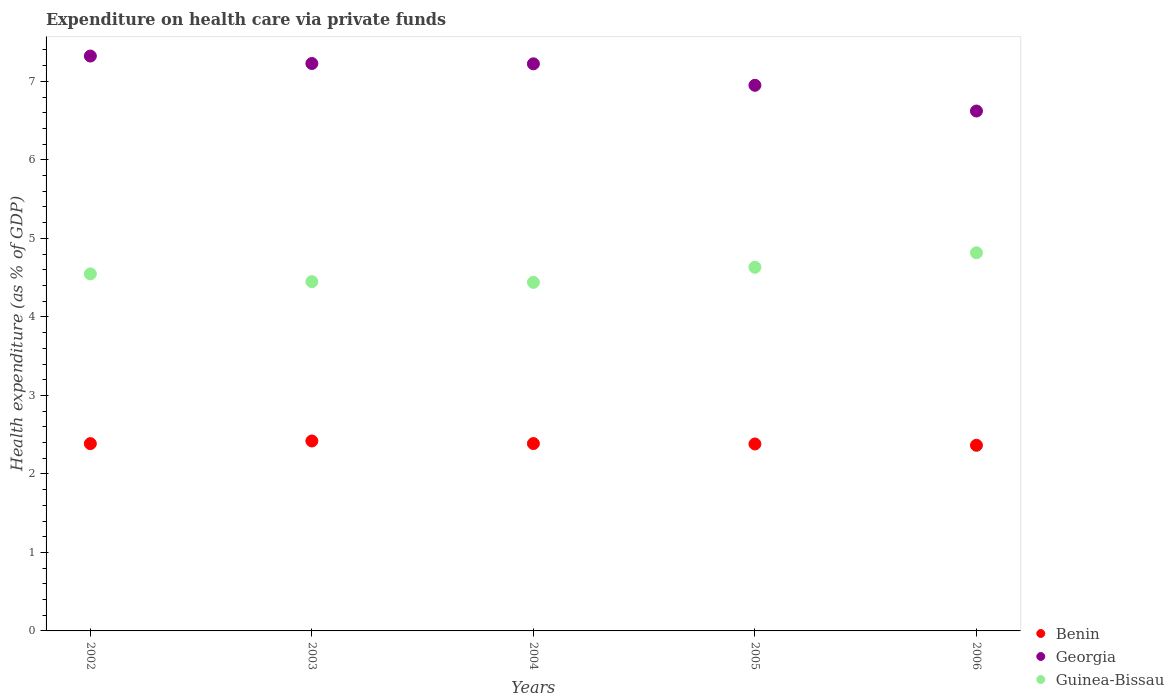How many different coloured dotlines are there?
Provide a succinct answer. 3. What is the expenditure made on health care in Guinea-Bissau in 2003?
Make the answer very short. 4.45. Across all years, what is the maximum expenditure made on health care in Georgia?
Your response must be concise. 7.32. Across all years, what is the minimum expenditure made on health care in Benin?
Your answer should be compact. 2.36. In which year was the expenditure made on health care in Guinea-Bissau minimum?
Keep it short and to the point. 2004. What is the total expenditure made on health care in Benin in the graph?
Your response must be concise. 11.94. What is the difference between the expenditure made on health care in Georgia in 2002 and that in 2003?
Ensure brevity in your answer.  0.1. What is the difference between the expenditure made on health care in Guinea-Bissau in 2004 and the expenditure made on health care in Georgia in 2002?
Make the answer very short. -2.88. What is the average expenditure made on health care in Guinea-Bissau per year?
Your answer should be very brief. 4.58. In the year 2005, what is the difference between the expenditure made on health care in Benin and expenditure made on health care in Guinea-Bissau?
Keep it short and to the point. -2.25. In how many years, is the expenditure made on health care in Benin greater than 6.8 %?
Offer a terse response. 0. What is the ratio of the expenditure made on health care in Benin in 2003 to that in 2005?
Keep it short and to the point. 1.02. Is the difference between the expenditure made on health care in Benin in 2005 and 2006 greater than the difference between the expenditure made on health care in Guinea-Bissau in 2005 and 2006?
Offer a terse response. Yes. What is the difference between the highest and the second highest expenditure made on health care in Georgia?
Your answer should be compact. 0.1. What is the difference between the highest and the lowest expenditure made on health care in Guinea-Bissau?
Offer a very short reply. 0.38. Is the sum of the expenditure made on health care in Guinea-Bissau in 2002 and 2004 greater than the maximum expenditure made on health care in Georgia across all years?
Ensure brevity in your answer.  Yes. Is it the case that in every year, the sum of the expenditure made on health care in Benin and expenditure made on health care in Georgia  is greater than the expenditure made on health care in Guinea-Bissau?
Give a very brief answer. Yes. Does the expenditure made on health care in Guinea-Bissau monotonically increase over the years?
Your response must be concise. No. Is the expenditure made on health care in Georgia strictly greater than the expenditure made on health care in Benin over the years?
Offer a very short reply. Yes. Is the expenditure made on health care in Benin strictly less than the expenditure made on health care in Guinea-Bissau over the years?
Make the answer very short. Yes. How many dotlines are there?
Give a very brief answer. 3. What is the difference between two consecutive major ticks on the Y-axis?
Your answer should be compact. 1. Are the values on the major ticks of Y-axis written in scientific E-notation?
Provide a succinct answer. No. Does the graph contain any zero values?
Offer a terse response. No. Does the graph contain grids?
Give a very brief answer. No. Where does the legend appear in the graph?
Provide a short and direct response. Bottom right. How many legend labels are there?
Your answer should be very brief. 3. What is the title of the graph?
Your response must be concise. Expenditure on health care via private funds. What is the label or title of the X-axis?
Offer a terse response. Years. What is the label or title of the Y-axis?
Provide a short and direct response. Health expenditure (as % of GDP). What is the Health expenditure (as % of GDP) in Benin in 2002?
Ensure brevity in your answer.  2.39. What is the Health expenditure (as % of GDP) of Georgia in 2002?
Ensure brevity in your answer.  7.32. What is the Health expenditure (as % of GDP) in Guinea-Bissau in 2002?
Offer a terse response. 4.55. What is the Health expenditure (as % of GDP) of Benin in 2003?
Provide a short and direct response. 2.42. What is the Health expenditure (as % of GDP) of Georgia in 2003?
Provide a succinct answer. 7.23. What is the Health expenditure (as % of GDP) in Guinea-Bissau in 2003?
Your answer should be very brief. 4.45. What is the Health expenditure (as % of GDP) of Benin in 2004?
Offer a very short reply. 2.39. What is the Health expenditure (as % of GDP) of Georgia in 2004?
Your response must be concise. 7.22. What is the Health expenditure (as % of GDP) of Guinea-Bissau in 2004?
Give a very brief answer. 4.44. What is the Health expenditure (as % of GDP) in Benin in 2005?
Offer a terse response. 2.38. What is the Health expenditure (as % of GDP) in Georgia in 2005?
Your answer should be very brief. 6.95. What is the Health expenditure (as % of GDP) in Guinea-Bissau in 2005?
Your response must be concise. 4.63. What is the Health expenditure (as % of GDP) of Benin in 2006?
Give a very brief answer. 2.36. What is the Health expenditure (as % of GDP) of Georgia in 2006?
Make the answer very short. 6.62. What is the Health expenditure (as % of GDP) of Guinea-Bissau in 2006?
Provide a short and direct response. 4.82. Across all years, what is the maximum Health expenditure (as % of GDP) of Benin?
Give a very brief answer. 2.42. Across all years, what is the maximum Health expenditure (as % of GDP) in Georgia?
Ensure brevity in your answer.  7.32. Across all years, what is the maximum Health expenditure (as % of GDP) in Guinea-Bissau?
Provide a succinct answer. 4.82. Across all years, what is the minimum Health expenditure (as % of GDP) of Benin?
Ensure brevity in your answer.  2.36. Across all years, what is the minimum Health expenditure (as % of GDP) of Georgia?
Provide a succinct answer. 6.62. Across all years, what is the minimum Health expenditure (as % of GDP) in Guinea-Bissau?
Provide a short and direct response. 4.44. What is the total Health expenditure (as % of GDP) in Benin in the graph?
Provide a succinct answer. 11.94. What is the total Health expenditure (as % of GDP) in Georgia in the graph?
Give a very brief answer. 35.35. What is the total Health expenditure (as % of GDP) of Guinea-Bissau in the graph?
Offer a terse response. 22.89. What is the difference between the Health expenditure (as % of GDP) in Benin in 2002 and that in 2003?
Ensure brevity in your answer.  -0.03. What is the difference between the Health expenditure (as % of GDP) of Georgia in 2002 and that in 2003?
Offer a very short reply. 0.1. What is the difference between the Health expenditure (as % of GDP) in Guinea-Bissau in 2002 and that in 2003?
Make the answer very short. 0.1. What is the difference between the Health expenditure (as % of GDP) in Benin in 2002 and that in 2004?
Ensure brevity in your answer.  -0. What is the difference between the Health expenditure (as % of GDP) of Georgia in 2002 and that in 2004?
Offer a very short reply. 0.1. What is the difference between the Health expenditure (as % of GDP) of Guinea-Bissau in 2002 and that in 2004?
Keep it short and to the point. 0.11. What is the difference between the Health expenditure (as % of GDP) in Benin in 2002 and that in 2005?
Your response must be concise. 0. What is the difference between the Health expenditure (as % of GDP) in Georgia in 2002 and that in 2005?
Keep it short and to the point. 0.37. What is the difference between the Health expenditure (as % of GDP) in Guinea-Bissau in 2002 and that in 2005?
Keep it short and to the point. -0.08. What is the difference between the Health expenditure (as % of GDP) in Benin in 2002 and that in 2006?
Offer a terse response. 0.02. What is the difference between the Health expenditure (as % of GDP) of Georgia in 2002 and that in 2006?
Ensure brevity in your answer.  0.7. What is the difference between the Health expenditure (as % of GDP) in Guinea-Bissau in 2002 and that in 2006?
Keep it short and to the point. -0.27. What is the difference between the Health expenditure (as % of GDP) in Benin in 2003 and that in 2004?
Your answer should be very brief. 0.03. What is the difference between the Health expenditure (as % of GDP) of Georgia in 2003 and that in 2004?
Provide a short and direct response. 0. What is the difference between the Health expenditure (as % of GDP) of Guinea-Bissau in 2003 and that in 2004?
Your answer should be compact. 0.01. What is the difference between the Health expenditure (as % of GDP) of Benin in 2003 and that in 2005?
Your answer should be compact. 0.04. What is the difference between the Health expenditure (as % of GDP) in Georgia in 2003 and that in 2005?
Your response must be concise. 0.28. What is the difference between the Health expenditure (as % of GDP) of Guinea-Bissau in 2003 and that in 2005?
Provide a short and direct response. -0.18. What is the difference between the Health expenditure (as % of GDP) of Benin in 2003 and that in 2006?
Offer a very short reply. 0.05. What is the difference between the Health expenditure (as % of GDP) in Georgia in 2003 and that in 2006?
Provide a succinct answer. 0.61. What is the difference between the Health expenditure (as % of GDP) in Guinea-Bissau in 2003 and that in 2006?
Provide a short and direct response. -0.37. What is the difference between the Health expenditure (as % of GDP) in Benin in 2004 and that in 2005?
Your answer should be compact. 0.01. What is the difference between the Health expenditure (as % of GDP) in Georgia in 2004 and that in 2005?
Your response must be concise. 0.27. What is the difference between the Health expenditure (as % of GDP) of Guinea-Bissau in 2004 and that in 2005?
Offer a very short reply. -0.19. What is the difference between the Health expenditure (as % of GDP) in Benin in 2004 and that in 2006?
Ensure brevity in your answer.  0.02. What is the difference between the Health expenditure (as % of GDP) of Georgia in 2004 and that in 2006?
Make the answer very short. 0.6. What is the difference between the Health expenditure (as % of GDP) of Guinea-Bissau in 2004 and that in 2006?
Your answer should be compact. -0.38. What is the difference between the Health expenditure (as % of GDP) in Benin in 2005 and that in 2006?
Ensure brevity in your answer.  0.02. What is the difference between the Health expenditure (as % of GDP) of Georgia in 2005 and that in 2006?
Keep it short and to the point. 0.33. What is the difference between the Health expenditure (as % of GDP) in Guinea-Bissau in 2005 and that in 2006?
Offer a terse response. -0.18. What is the difference between the Health expenditure (as % of GDP) of Benin in 2002 and the Health expenditure (as % of GDP) of Georgia in 2003?
Offer a very short reply. -4.84. What is the difference between the Health expenditure (as % of GDP) of Benin in 2002 and the Health expenditure (as % of GDP) of Guinea-Bissau in 2003?
Your answer should be compact. -2.06. What is the difference between the Health expenditure (as % of GDP) of Georgia in 2002 and the Health expenditure (as % of GDP) of Guinea-Bissau in 2003?
Offer a terse response. 2.87. What is the difference between the Health expenditure (as % of GDP) of Benin in 2002 and the Health expenditure (as % of GDP) of Georgia in 2004?
Offer a terse response. -4.84. What is the difference between the Health expenditure (as % of GDP) of Benin in 2002 and the Health expenditure (as % of GDP) of Guinea-Bissau in 2004?
Provide a succinct answer. -2.05. What is the difference between the Health expenditure (as % of GDP) in Georgia in 2002 and the Health expenditure (as % of GDP) in Guinea-Bissau in 2004?
Provide a succinct answer. 2.88. What is the difference between the Health expenditure (as % of GDP) of Benin in 2002 and the Health expenditure (as % of GDP) of Georgia in 2005?
Offer a terse response. -4.56. What is the difference between the Health expenditure (as % of GDP) in Benin in 2002 and the Health expenditure (as % of GDP) in Guinea-Bissau in 2005?
Offer a very short reply. -2.25. What is the difference between the Health expenditure (as % of GDP) of Georgia in 2002 and the Health expenditure (as % of GDP) of Guinea-Bissau in 2005?
Your response must be concise. 2.69. What is the difference between the Health expenditure (as % of GDP) of Benin in 2002 and the Health expenditure (as % of GDP) of Georgia in 2006?
Offer a terse response. -4.24. What is the difference between the Health expenditure (as % of GDP) of Benin in 2002 and the Health expenditure (as % of GDP) of Guinea-Bissau in 2006?
Ensure brevity in your answer.  -2.43. What is the difference between the Health expenditure (as % of GDP) of Georgia in 2002 and the Health expenditure (as % of GDP) of Guinea-Bissau in 2006?
Offer a very short reply. 2.51. What is the difference between the Health expenditure (as % of GDP) in Benin in 2003 and the Health expenditure (as % of GDP) in Georgia in 2004?
Provide a succinct answer. -4.8. What is the difference between the Health expenditure (as % of GDP) of Benin in 2003 and the Health expenditure (as % of GDP) of Guinea-Bissau in 2004?
Your response must be concise. -2.02. What is the difference between the Health expenditure (as % of GDP) of Georgia in 2003 and the Health expenditure (as % of GDP) of Guinea-Bissau in 2004?
Give a very brief answer. 2.79. What is the difference between the Health expenditure (as % of GDP) of Benin in 2003 and the Health expenditure (as % of GDP) of Georgia in 2005?
Give a very brief answer. -4.53. What is the difference between the Health expenditure (as % of GDP) in Benin in 2003 and the Health expenditure (as % of GDP) in Guinea-Bissau in 2005?
Your response must be concise. -2.21. What is the difference between the Health expenditure (as % of GDP) of Georgia in 2003 and the Health expenditure (as % of GDP) of Guinea-Bissau in 2005?
Provide a short and direct response. 2.6. What is the difference between the Health expenditure (as % of GDP) of Benin in 2003 and the Health expenditure (as % of GDP) of Georgia in 2006?
Your answer should be compact. -4.2. What is the difference between the Health expenditure (as % of GDP) in Benin in 2003 and the Health expenditure (as % of GDP) in Guinea-Bissau in 2006?
Your response must be concise. -2.4. What is the difference between the Health expenditure (as % of GDP) of Georgia in 2003 and the Health expenditure (as % of GDP) of Guinea-Bissau in 2006?
Give a very brief answer. 2.41. What is the difference between the Health expenditure (as % of GDP) in Benin in 2004 and the Health expenditure (as % of GDP) in Georgia in 2005?
Offer a very short reply. -4.56. What is the difference between the Health expenditure (as % of GDP) of Benin in 2004 and the Health expenditure (as % of GDP) of Guinea-Bissau in 2005?
Offer a very short reply. -2.25. What is the difference between the Health expenditure (as % of GDP) in Georgia in 2004 and the Health expenditure (as % of GDP) in Guinea-Bissau in 2005?
Make the answer very short. 2.59. What is the difference between the Health expenditure (as % of GDP) in Benin in 2004 and the Health expenditure (as % of GDP) in Georgia in 2006?
Give a very brief answer. -4.24. What is the difference between the Health expenditure (as % of GDP) in Benin in 2004 and the Health expenditure (as % of GDP) in Guinea-Bissau in 2006?
Offer a terse response. -2.43. What is the difference between the Health expenditure (as % of GDP) in Georgia in 2004 and the Health expenditure (as % of GDP) in Guinea-Bissau in 2006?
Keep it short and to the point. 2.41. What is the difference between the Health expenditure (as % of GDP) of Benin in 2005 and the Health expenditure (as % of GDP) of Georgia in 2006?
Ensure brevity in your answer.  -4.24. What is the difference between the Health expenditure (as % of GDP) in Benin in 2005 and the Health expenditure (as % of GDP) in Guinea-Bissau in 2006?
Your answer should be compact. -2.44. What is the difference between the Health expenditure (as % of GDP) of Georgia in 2005 and the Health expenditure (as % of GDP) of Guinea-Bissau in 2006?
Provide a short and direct response. 2.13. What is the average Health expenditure (as % of GDP) of Benin per year?
Your response must be concise. 2.39. What is the average Health expenditure (as % of GDP) in Georgia per year?
Provide a succinct answer. 7.07. What is the average Health expenditure (as % of GDP) in Guinea-Bissau per year?
Your answer should be very brief. 4.58. In the year 2002, what is the difference between the Health expenditure (as % of GDP) of Benin and Health expenditure (as % of GDP) of Georgia?
Give a very brief answer. -4.94. In the year 2002, what is the difference between the Health expenditure (as % of GDP) of Benin and Health expenditure (as % of GDP) of Guinea-Bissau?
Your answer should be very brief. -2.16. In the year 2002, what is the difference between the Health expenditure (as % of GDP) in Georgia and Health expenditure (as % of GDP) in Guinea-Bissau?
Provide a short and direct response. 2.77. In the year 2003, what is the difference between the Health expenditure (as % of GDP) in Benin and Health expenditure (as % of GDP) in Georgia?
Offer a terse response. -4.81. In the year 2003, what is the difference between the Health expenditure (as % of GDP) in Benin and Health expenditure (as % of GDP) in Guinea-Bissau?
Provide a short and direct response. -2.03. In the year 2003, what is the difference between the Health expenditure (as % of GDP) of Georgia and Health expenditure (as % of GDP) of Guinea-Bissau?
Your response must be concise. 2.78. In the year 2004, what is the difference between the Health expenditure (as % of GDP) in Benin and Health expenditure (as % of GDP) in Georgia?
Your answer should be compact. -4.84. In the year 2004, what is the difference between the Health expenditure (as % of GDP) of Benin and Health expenditure (as % of GDP) of Guinea-Bissau?
Your answer should be very brief. -2.05. In the year 2004, what is the difference between the Health expenditure (as % of GDP) of Georgia and Health expenditure (as % of GDP) of Guinea-Bissau?
Offer a terse response. 2.78. In the year 2005, what is the difference between the Health expenditure (as % of GDP) of Benin and Health expenditure (as % of GDP) of Georgia?
Provide a succinct answer. -4.57. In the year 2005, what is the difference between the Health expenditure (as % of GDP) of Benin and Health expenditure (as % of GDP) of Guinea-Bissau?
Provide a short and direct response. -2.25. In the year 2005, what is the difference between the Health expenditure (as % of GDP) of Georgia and Health expenditure (as % of GDP) of Guinea-Bissau?
Give a very brief answer. 2.32. In the year 2006, what is the difference between the Health expenditure (as % of GDP) in Benin and Health expenditure (as % of GDP) in Georgia?
Provide a succinct answer. -4.26. In the year 2006, what is the difference between the Health expenditure (as % of GDP) in Benin and Health expenditure (as % of GDP) in Guinea-Bissau?
Your response must be concise. -2.45. In the year 2006, what is the difference between the Health expenditure (as % of GDP) of Georgia and Health expenditure (as % of GDP) of Guinea-Bissau?
Give a very brief answer. 1.81. What is the ratio of the Health expenditure (as % of GDP) of Benin in 2002 to that in 2003?
Provide a short and direct response. 0.99. What is the ratio of the Health expenditure (as % of GDP) in Georgia in 2002 to that in 2003?
Give a very brief answer. 1.01. What is the ratio of the Health expenditure (as % of GDP) of Guinea-Bissau in 2002 to that in 2003?
Your answer should be compact. 1.02. What is the ratio of the Health expenditure (as % of GDP) in Benin in 2002 to that in 2004?
Offer a terse response. 1. What is the ratio of the Health expenditure (as % of GDP) of Georgia in 2002 to that in 2004?
Give a very brief answer. 1.01. What is the ratio of the Health expenditure (as % of GDP) in Guinea-Bissau in 2002 to that in 2004?
Your response must be concise. 1.02. What is the ratio of the Health expenditure (as % of GDP) of Benin in 2002 to that in 2005?
Your answer should be very brief. 1. What is the ratio of the Health expenditure (as % of GDP) of Georgia in 2002 to that in 2005?
Give a very brief answer. 1.05. What is the ratio of the Health expenditure (as % of GDP) of Guinea-Bissau in 2002 to that in 2005?
Provide a succinct answer. 0.98. What is the ratio of the Health expenditure (as % of GDP) of Benin in 2002 to that in 2006?
Your answer should be compact. 1.01. What is the ratio of the Health expenditure (as % of GDP) in Georgia in 2002 to that in 2006?
Your response must be concise. 1.11. What is the ratio of the Health expenditure (as % of GDP) of Guinea-Bissau in 2002 to that in 2006?
Your response must be concise. 0.94. What is the ratio of the Health expenditure (as % of GDP) in Benin in 2003 to that in 2004?
Keep it short and to the point. 1.01. What is the ratio of the Health expenditure (as % of GDP) of Guinea-Bissau in 2003 to that in 2004?
Ensure brevity in your answer.  1. What is the ratio of the Health expenditure (as % of GDP) of Georgia in 2003 to that in 2005?
Offer a terse response. 1.04. What is the ratio of the Health expenditure (as % of GDP) of Guinea-Bissau in 2003 to that in 2005?
Offer a terse response. 0.96. What is the ratio of the Health expenditure (as % of GDP) of Benin in 2003 to that in 2006?
Give a very brief answer. 1.02. What is the ratio of the Health expenditure (as % of GDP) of Georgia in 2003 to that in 2006?
Offer a very short reply. 1.09. What is the ratio of the Health expenditure (as % of GDP) in Guinea-Bissau in 2003 to that in 2006?
Provide a short and direct response. 0.92. What is the ratio of the Health expenditure (as % of GDP) of Georgia in 2004 to that in 2005?
Offer a terse response. 1.04. What is the ratio of the Health expenditure (as % of GDP) in Guinea-Bissau in 2004 to that in 2005?
Provide a short and direct response. 0.96. What is the ratio of the Health expenditure (as % of GDP) of Benin in 2004 to that in 2006?
Your answer should be very brief. 1.01. What is the ratio of the Health expenditure (as % of GDP) of Georgia in 2004 to that in 2006?
Your answer should be compact. 1.09. What is the ratio of the Health expenditure (as % of GDP) of Guinea-Bissau in 2004 to that in 2006?
Keep it short and to the point. 0.92. What is the ratio of the Health expenditure (as % of GDP) of Georgia in 2005 to that in 2006?
Offer a terse response. 1.05. What is the ratio of the Health expenditure (as % of GDP) in Guinea-Bissau in 2005 to that in 2006?
Keep it short and to the point. 0.96. What is the difference between the highest and the second highest Health expenditure (as % of GDP) of Benin?
Provide a short and direct response. 0.03. What is the difference between the highest and the second highest Health expenditure (as % of GDP) of Georgia?
Give a very brief answer. 0.1. What is the difference between the highest and the second highest Health expenditure (as % of GDP) in Guinea-Bissau?
Keep it short and to the point. 0.18. What is the difference between the highest and the lowest Health expenditure (as % of GDP) of Benin?
Ensure brevity in your answer.  0.05. What is the difference between the highest and the lowest Health expenditure (as % of GDP) in Georgia?
Provide a short and direct response. 0.7. What is the difference between the highest and the lowest Health expenditure (as % of GDP) of Guinea-Bissau?
Your answer should be very brief. 0.38. 